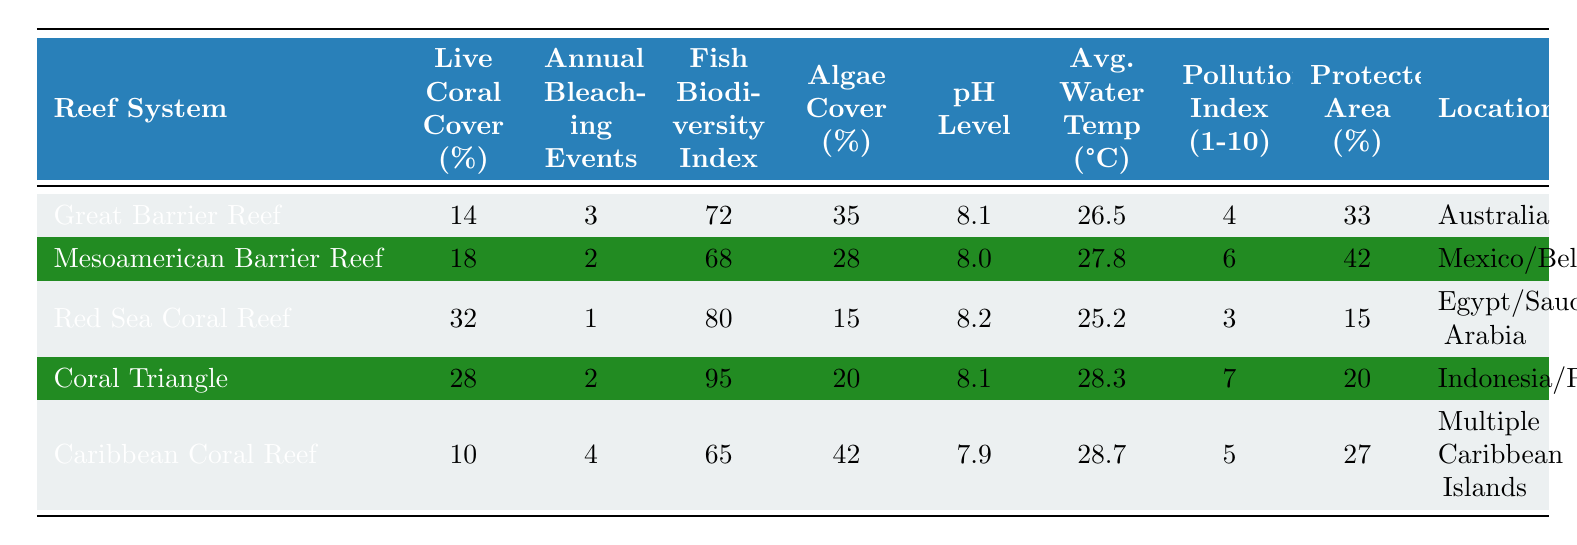What is the Live Coral Cover percentage for the Red Sea Coral Reef? According to the table, the Live Coral Cover percentage for the Red Sea Coral Reef is listed as 32%.
Answer: 32% Which reef system has the highest Fish Biodiversity Index? The table shows that the Coral Triangle has the highest Fish Biodiversity Index at 95, compared to the other reef systems.
Answer: Coral Triangle How many Annual Bleaching Events does the Caribbean Coral Reef experience? The Caribbean Coral Reef has 4 Annual Bleaching Events according to the table.
Answer: 4 What is the average Live Coral Cover percentage across all the reef systems? To find the average, add the percentages (14 + 18 + 32 + 28 + 10) = 102, then divide by 5 (the number of reef systems) resulting in an average of 20.4%.
Answer: 20.4% Is the pH Level in the Coral Triangle higher than that in the Great Barrier Reef? The table indicates that both the Coral Triangle and the Great Barrier Reef have a pH Level of 8.1, which means they are equal, not that one is higher.
Answer: No Which reef system has the lowest Pollution Index? The lowest Pollution Index is for the Red Sea Coral Reef, which has a Pollution Index of 3.
Answer: Red Sea Coral Reef How does the average water temperature compare between the Great Barrier Reef and the Mesoamerican Barrier Reef? The average water temperature for the Great Barrier Reef is 26.5°C and for the Mesoamerican Barrier Reef, it is 27.8°C. The Mesoamerican Barrier Reef has a higher temperature by 1.3°C.
Answer: Mesoamerican Barrier Reef has a higher temperature What is the difference in Algae Cover percentage between the Caribbean Coral Reef and the Red Sea Coral Reef? The Algae Cover for the Caribbean Coral Reef is 42% and for the Red Sea Coral Reef is 15%. The difference is calculated as 42 - 15 = 27%.
Answer: 27% Which reef system contains the largest protected area percentage? The Mesoamerican Barrier Reef has the largest protected area percentage listed at 42%.
Answer: Mesoamerican Barrier Reef If we were to combine the Live Coral Cover from both the Coral Triangle and the Great Barrier Reef, what would that total be? The Live Coral Cover for the Coral Triangle is 28% and for the Great Barrier Reef is 14%. Adding them together gives 28 + 14 = 42%.
Answer: 42% 